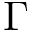<formula> <loc_0><loc_0><loc_500><loc_500>\Gamma</formula> 